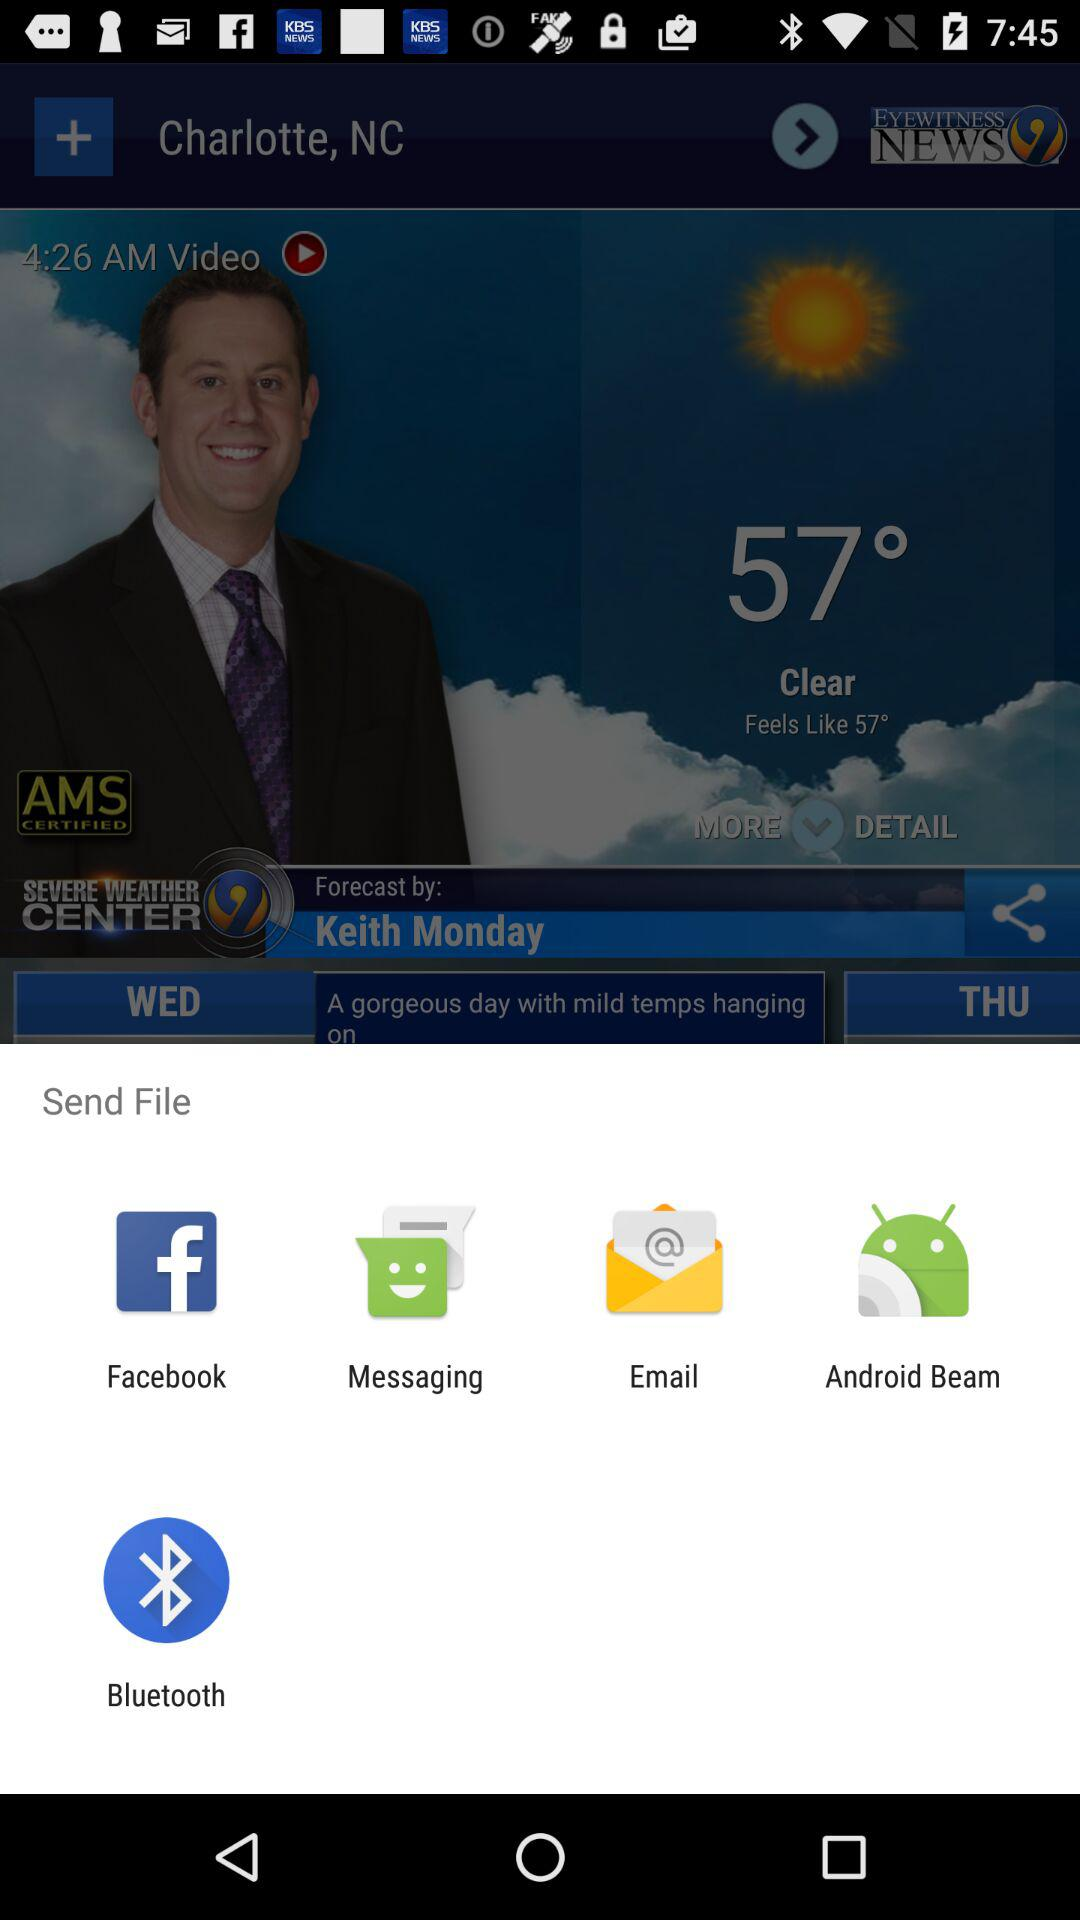What is the news channel name? The news channel name is EYEWITNESS NEWS 9. 